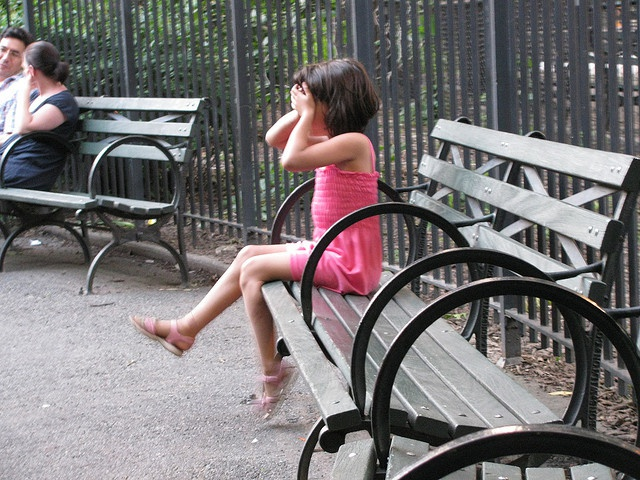Describe the objects in this image and their specific colors. I can see bench in teal, black, lightgray, darkgray, and gray tones, bench in teal, black, darkgray, gray, and lightgray tones, people in teal, brown, black, lightgray, and lightpink tones, bench in teal, black, gray, lightgray, and darkgray tones, and people in teal, black, white, gray, and lightpink tones in this image. 